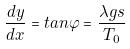Convert formula to latex. <formula><loc_0><loc_0><loc_500><loc_500>\frac { d y } { d x } = t a n \varphi = \frac { \lambda g s } { T _ { 0 } }</formula> 